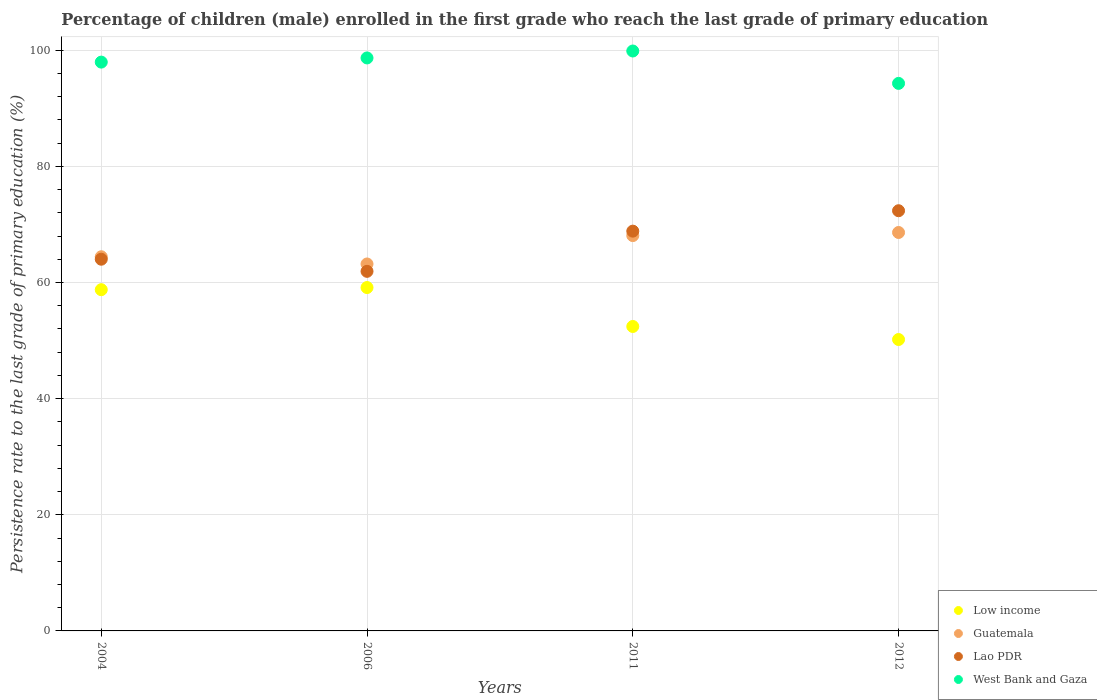How many different coloured dotlines are there?
Provide a short and direct response. 4. What is the persistence rate of children in Lao PDR in 2006?
Ensure brevity in your answer.  61.93. Across all years, what is the maximum persistence rate of children in Low income?
Keep it short and to the point. 59.14. Across all years, what is the minimum persistence rate of children in Low income?
Offer a very short reply. 50.18. What is the total persistence rate of children in Guatemala in the graph?
Your response must be concise. 264.33. What is the difference between the persistence rate of children in West Bank and Gaza in 2004 and that in 2006?
Give a very brief answer. -0.72. What is the difference between the persistence rate of children in West Bank and Gaza in 2006 and the persistence rate of children in Low income in 2004?
Make the answer very short. 39.91. What is the average persistence rate of children in West Bank and Gaza per year?
Your answer should be very brief. 97.7. In the year 2004, what is the difference between the persistence rate of children in Guatemala and persistence rate of children in West Bank and Gaza?
Offer a very short reply. -33.52. What is the ratio of the persistence rate of children in West Bank and Gaza in 2006 to that in 2012?
Make the answer very short. 1.05. What is the difference between the highest and the second highest persistence rate of children in Lao PDR?
Your answer should be compact. 3.52. What is the difference between the highest and the lowest persistence rate of children in Lao PDR?
Provide a succinct answer. 10.44. Is the sum of the persistence rate of children in Low income in 2011 and 2012 greater than the maximum persistence rate of children in West Bank and Gaza across all years?
Offer a very short reply. Yes. Is it the case that in every year, the sum of the persistence rate of children in Lao PDR and persistence rate of children in Low income  is greater than the sum of persistence rate of children in West Bank and Gaza and persistence rate of children in Guatemala?
Offer a very short reply. No. Does the persistence rate of children in Low income monotonically increase over the years?
Give a very brief answer. No. Is the persistence rate of children in West Bank and Gaza strictly greater than the persistence rate of children in Lao PDR over the years?
Keep it short and to the point. Yes. Is the persistence rate of children in Low income strictly less than the persistence rate of children in West Bank and Gaza over the years?
Provide a short and direct response. Yes. How many dotlines are there?
Provide a succinct answer. 4. How many years are there in the graph?
Offer a very short reply. 4. Are the values on the major ticks of Y-axis written in scientific E-notation?
Offer a terse response. No. Does the graph contain any zero values?
Ensure brevity in your answer.  No. How many legend labels are there?
Your response must be concise. 4. What is the title of the graph?
Provide a short and direct response. Percentage of children (male) enrolled in the first grade who reach the last grade of primary education. What is the label or title of the X-axis?
Your answer should be very brief. Years. What is the label or title of the Y-axis?
Your answer should be compact. Persistence rate to the last grade of primary education (%). What is the Persistence rate to the last grade of primary education (%) in Low income in 2004?
Offer a very short reply. 58.77. What is the Persistence rate to the last grade of primary education (%) of Guatemala in 2004?
Keep it short and to the point. 64.44. What is the Persistence rate to the last grade of primary education (%) in Lao PDR in 2004?
Ensure brevity in your answer.  64.01. What is the Persistence rate to the last grade of primary education (%) of West Bank and Gaza in 2004?
Offer a very short reply. 97.96. What is the Persistence rate to the last grade of primary education (%) in Low income in 2006?
Make the answer very short. 59.14. What is the Persistence rate to the last grade of primary education (%) in Guatemala in 2006?
Make the answer very short. 63.19. What is the Persistence rate to the last grade of primary education (%) of Lao PDR in 2006?
Offer a very short reply. 61.93. What is the Persistence rate to the last grade of primary education (%) in West Bank and Gaza in 2006?
Provide a short and direct response. 98.68. What is the Persistence rate to the last grade of primary education (%) in Low income in 2011?
Make the answer very short. 52.43. What is the Persistence rate to the last grade of primary education (%) in Guatemala in 2011?
Provide a short and direct response. 68.08. What is the Persistence rate to the last grade of primary education (%) of Lao PDR in 2011?
Ensure brevity in your answer.  68.85. What is the Persistence rate to the last grade of primary education (%) in West Bank and Gaza in 2011?
Make the answer very short. 99.87. What is the Persistence rate to the last grade of primary education (%) of Low income in 2012?
Offer a terse response. 50.18. What is the Persistence rate to the last grade of primary education (%) in Guatemala in 2012?
Your answer should be compact. 68.62. What is the Persistence rate to the last grade of primary education (%) of Lao PDR in 2012?
Give a very brief answer. 72.36. What is the Persistence rate to the last grade of primary education (%) of West Bank and Gaza in 2012?
Offer a terse response. 94.29. Across all years, what is the maximum Persistence rate to the last grade of primary education (%) of Low income?
Your answer should be very brief. 59.14. Across all years, what is the maximum Persistence rate to the last grade of primary education (%) in Guatemala?
Provide a short and direct response. 68.62. Across all years, what is the maximum Persistence rate to the last grade of primary education (%) of Lao PDR?
Offer a very short reply. 72.36. Across all years, what is the maximum Persistence rate to the last grade of primary education (%) of West Bank and Gaza?
Provide a succinct answer. 99.87. Across all years, what is the minimum Persistence rate to the last grade of primary education (%) in Low income?
Offer a terse response. 50.18. Across all years, what is the minimum Persistence rate to the last grade of primary education (%) in Guatemala?
Provide a short and direct response. 63.19. Across all years, what is the minimum Persistence rate to the last grade of primary education (%) of Lao PDR?
Offer a very short reply. 61.93. Across all years, what is the minimum Persistence rate to the last grade of primary education (%) in West Bank and Gaza?
Ensure brevity in your answer.  94.29. What is the total Persistence rate to the last grade of primary education (%) in Low income in the graph?
Give a very brief answer. 220.52. What is the total Persistence rate to the last grade of primary education (%) in Guatemala in the graph?
Offer a very short reply. 264.33. What is the total Persistence rate to the last grade of primary education (%) in Lao PDR in the graph?
Give a very brief answer. 267.15. What is the total Persistence rate to the last grade of primary education (%) in West Bank and Gaza in the graph?
Give a very brief answer. 390.8. What is the difference between the Persistence rate to the last grade of primary education (%) in Low income in 2004 and that in 2006?
Offer a very short reply. -0.37. What is the difference between the Persistence rate to the last grade of primary education (%) in Guatemala in 2004 and that in 2006?
Offer a very short reply. 1.24. What is the difference between the Persistence rate to the last grade of primary education (%) in Lao PDR in 2004 and that in 2006?
Give a very brief answer. 2.09. What is the difference between the Persistence rate to the last grade of primary education (%) in West Bank and Gaza in 2004 and that in 2006?
Your answer should be compact. -0.72. What is the difference between the Persistence rate to the last grade of primary education (%) of Low income in 2004 and that in 2011?
Offer a terse response. 6.34. What is the difference between the Persistence rate to the last grade of primary education (%) of Guatemala in 2004 and that in 2011?
Your answer should be very brief. -3.65. What is the difference between the Persistence rate to the last grade of primary education (%) in Lao PDR in 2004 and that in 2011?
Ensure brevity in your answer.  -4.83. What is the difference between the Persistence rate to the last grade of primary education (%) in West Bank and Gaza in 2004 and that in 2011?
Make the answer very short. -1.91. What is the difference between the Persistence rate to the last grade of primary education (%) in Low income in 2004 and that in 2012?
Make the answer very short. 8.58. What is the difference between the Persistence rate to the last grade of primary education (%) in Guatemala in 2004 and that in 2012?
Offer a terse response. -4.18. What is the difference between the Persistence rate to the last grade of primary education (%) in Lao PDR in 2004 and that in 2012?
Keep it short and to the point. -8.35. What is the difference between the Persistence rate to the last grade of primary education (%) of West Bank and Gaza in 2004 and that in 2012?
Give a very brief answer. 3.66. What is the difference between the Persistence rate to the last grade of primary education (%) of Low income in 2006 and that in 2011?
Your answer should be compact. 6.71. What is the difference between the Persistence rate to the last grade of primary education (%) in Guatemala in 2006 and that in 2011?
Your response must be concise. -4.89. What is the difference between the Persistence rate to the last grade of primary education (%) in Lao PDR in 2006 and that in 2011?
Offer a very short reply. -6.92. What is the difference between the Persistence rate to the last grade of primary education (%) of West Bank and Gaza in 2006 and that in 2011?
Give a very brief answer. -1.19. What is the difference between the Persistence rate to the last grade of primary education (%) in Low income in 2006 and that in 2012?
Offer a terse response. 8.95. What is the difference between the Persistence rate to the last grade of primary education (%) in Guatemala in 2006 and that in 2012?
Ensure brevity in your answer.  -5.42. What is the difference between the Persistence rate to the last grade of primary education (%) in Lao PDR in 2006 and that in 2012?
Provide a short and direct response. -10.44. What is the difference between the Persistence rate to the last grade of primary education (%) in West Bank and Gaza in 2006 and that in 2012?
Your answer should be compact. 4.38. What is the difference between the Persistence rate to the last grade of primary education (%) in Low income in 2011 and that in 2012?
Provide a succinct answer. 2.25. What is the difference between the Persistence rate to the last grade of primary education (%) of Guatemala in 2011 and that in 2012?
Make the answer very short. -0.53. What is the difference between the Persistence rate to the last grade of primary education (%) of Lao PDR in 2011 and that in 2012?
Give a very brief answer. -3.52. What is the difference between the Persistence rate to the last grade of primary education (%) in West Bank and Gaza in 2011 and that in 2012?
Offer a terse response. 5.58. What is the difference between the Persistence rate to the last grade of primary education (%) of Low income in 2004 and the Persistence rate to the last grade of primary education (%) of Guatemala in 2006?
Your answer should be very brief. -4.43. What is the difference between the Persistence rate to the last grade of primary education (%) of Low income in 2004 and the Persistence rate to the last grade of primary education (%) of Lao PDR in 2006?
Offer a very short reply. -3.16. What is the difference between the Persistence rate to the last grade of primary education (%) of Low income in 2004 and the Persistence rate to the last grade of primary education (%) of West Bank and Gaza in 2006?
Offer a very short reply. -39.91. What is the difference between the Persistence rate to the last grade of primary education (%) of Guatemala in 2004 and the Persistence rate to the last grade of primary education (%) of Lao PDR in 2006?
Your answer should be compact. 2.51. What is the difference between the Persistence rate to the last grade of primary education (%) in Guatemala in 2004 and the Persistence rate to the last grade of primary education (%) in West Bank and Gaza in 2006?
Keep it short and to the point. -34.24. What is the difference between the Persistence rate to the last grade of primary education (%) in Lao PDR in 2004 and the Persistence rate to the last grade of primary education (%) in West Bank and Gaza in 2006?
Make the answer very short. -34.66. What is the difference between the Persistence rate to the last grade of primary education (%) of Low income in 2004 and the Persistence rate to the last grade of primary education (%) of Guatemala in 2011?
Give a very brief answer. -9.32. What is the difference between the Persistence rate to the last grade of primary education (%) of Low income in 2004 and the Persistence rate to the last grade of primary education (%) of Lao PDR in 2011?
Your answer should be very brief. -10.08. What is the difference between the Persistence rate to the last grade of primary education (%) in Low income in 2004 and the Persistence rate to the last grade of primary education (%) in West Bank and Gaza in 2011?
Your answer should be compact. -41.1. What is the difference between the Persistence rate to the last grade of primary education (%) of Guatemala in 2004 and the Persistence rate to the last grade of primary education (%) of Lao PDR in 2011?
Give a very brief answer. -4.41. What is the difference between the Persistence rate to the last grade of primary education (%) of Guatemala in 2004 and the Persistence rate to the last grade of primary education (%) of West Bank and Gaza in 2011?
Keep it short and to the point. -35.43. What is the difference between the Persistence rate to the last grade of primary education (%) in Lao PDR in 2004 and the Persistence rate to the last grade of primary education (%) in West Bank and Gaza in 2011?
Ensure brevity in your answer.  -35.86. What is the difference between the Persistence rate to the last grade of primary education (%) in Low income in 2004 and the Persistence rate to the last grade of primary education (%) in Guatemala in 2012?
Offer a very short reply. -9.85. What is the difference between the Persistence rate to the last grade of primary education (%) in Low income in 2004 and the Persistence rate to the last grade of primary education (%) in Lao PDR in 2012?
Offer a very short reply. -13.6. What is the difference between the Persistence rate to the last grade of primary education (%) of Low income in 2004 and the Persistence rate to the last grade of primary education (%) of West Bank and Gaza in 2012?
Provide a succinct answer. -35.53. What is the difference between the Persistence rate to the last grade of primary education (%) of Guatemala in 2004 and the Persistence rate to the last grade of primary education (%) of Lao PDR in 2012?
Your answer should be very brief. -7.93. What is the difference between the Persistence rate to the last grade of primary education (%) in Guatemala in 2004 and the Persistence rate to the last grade of primary education (%) in West Bank and Gaza in 2012?
Keep it short and to the point. -29.86. What is the difference between the Persistence rate to the last grade of primary education (%) of Lao PDR in 2004 and the Persistence rate to the last grade of primary education (%) of West Bank and Gaza in 2012?
Make the answer very short. -30.28. What is the difference between the Persistence rate to the last grade of primary education (%) in Low income in 2006 and the Persistence rate to the last grade of primary education (%) in Guatemala in 2011?
Provide a short and direct response. -8.95. What is the difference between the Persistence rate to the last grade of primary education (%) of Low income in 2006 and the Persistence rate to the last grade of primary education (%) of Lao PDR in 2011?
Provide a short and direct response. -9.71. What is the difference between the Persistence rate to the last grade of primary education (%) in Low income in 2006 and the Persistence rate to the last grade of primary education (%) in West Bank and Gaza in 2011?
Your answer should be compact. -40.74. What is the difference between the Persistence rate to the last grade of primary education (%) in Guatemala in 2006 and the Persistence rate to the last grade of primary education (%) in Lao PDR in 2011?
Give a very brief answer. -5.65. What is the difference between the Persistence rate to the last grade of primary education (%) of Guatemala in 2006 and the Persistence rate to the last grade of primary education (%) of West Bank and Gaza in 2011?
Your answer should be compact. -36.68. What is the difference between the Persistence rate to the last grade of primary education (%) in Lao PDR in 2006 and the Persistence rate to the last grade of primary education (%) in West Bank and Gaza in 2011?
Give a very brief answer. -37.94. What is the difference between the Persistence rate to the last grade of primary education (%) in Low income in 2006 and the Persistence rate to the last grade of primary education (%) in Guatemala in 2012?
Offer a very short reply. -9.48. What is the difference between the Persistence rate to the last grade of primary education (%) of Low income in 2006 and the Persistence rate to the last grade of primary education (%) of Lao PDR in 2012?
Keep it short and to the point. -13.23. What is the difference between the Persistence rate to the last grade of primary education (%) in Low income in 2006 and the Persistence rate to the last grade of primary education (%) in West Bank and Gaza in 2012?
Keep it short and to the point. -35.16. What is the difference between the Persistence rate to the last grade of primary education (%) in Guatemala in 2006 and the Persistence rate to the last grade of primary education (%) in Lao PDR in 2012?
Offer a very short reply. -9.17. What is the difference between the Persistence rate to the last grade of primary education (%) in Guatemala in 2006 and the Persistence rate to the last grade of primary education (%) in West Bank and Gaza in 2012?
Your answer should be very brief. -31.1. What is the difference between the Persistence rate to the last grade of primary education (%) in Lao PDR in 2006 and the Persistence rate to the last grade of primary education (%) in West Bank and Gaza in 2012?
Keep it short and to the point. -32.37. What is the difference between the Persistence rate to the last grade of primary education (%) in Low income in 2011 and the Persistence rate to the last grade of primary education (%) in Guatemala in 2012?
Give a very brief answer. -16.19. What is the difference between the Persistence rate to the last grade of primary education (%) in Low income in 2011 and the Persistence rate to the last grade of primary education (%) in Lao PDR in 2012?
Offer a terse response. -19.93. What is the difference between the Persistence rate to the last grade of primary education (%) of Low income in 2011 and the Persistence rate to the last grade of primary education (%) of West Bank and Gaza in 2012?
Ensure brevity in your answer.  -41.86. What is the difference between the Persistence rate to the last grade of primary education (%) in Guatemala in 2011 and the Persistence rate to the last grade of primary education (%) in Lao PDR in 2012?
Make the answer very short. -4.28. What is the difference between the Persistence rate to the last grade of primary education (%) of Guatemala in 2011 and the Persistence rate to the last grade of primary education (%) of West Bank and Gaza in 2012?
Give a very brief answer. -26.21. What is the difference between the Persistence rate to the last grade of primary education (%) in Lao PDR in 2011 and the Persistence rate to the last grade of primary education (%) in West Bank and Gaza in 2012?
Your answer should be very brief. -25.45. What is the average Persistence rate to the last grade of primary education (%) of Low income per year?
Ensure brevity in your answer.  55.13. What is the average Persistence rate to the last grade of primary education (%) in Guatemala per year?
Provide a succinct answer. 66.08. What is the average Persistence rate to the last grade of primary education (%) of Lao PDR per year?
Give a very brief answer. 66.79. What is the average Persistence rate to the last grade of primary education (%) in West Bank and Gaza per year?
Give a very brief answer. 97.7. In the year 2004, what is the difference between the Persistence rate to the last grade of primary education (%) in Low income and Persistence rate to the last grade of primary education (%) in Guatemala?
Provide a succinct answer. -5.67. In the year 2004, what is the difference between the Persistence rate to the last grade of primary education (%) of Low income and Persistence rate to the last grade of primary education (%) of Lao PDR?
Provide a short and direct response. -5.25. In the year 2004, what is the difference between the Persistence rate to the last grade of primary education (%) in Low income and Persistence rate to the last grade of primary education (%) in West Bank and Gaza?
Your answer should be compact. -39.19. In the year 2004, what is the difference between the Persistence rate to the last grade of primary education (%) of Guatemala and Persistence rate to the last grade of primary education (%) of Lao PDR?
Ensure brevity in your answer.  0.42. In the year 2004, what is the difference between the Persistence rate to the last grade of primary education (%) of Guatemala and Persistence rate to the last grade of primary education (%) of West Bank and Gaza?
Make the answer very short. -33.52. In the year 2004, what is the difference between the Persistence rate to the last grade of primary education (%) in Lao PDR and Persistence rate to the last grade of primary education (%) in West Bank and Gaza?
Your answer should be very brief. -33.94. In the year 2006, what is the difference between the Persistence rate to the last grade of primary education (%) in Low income and Persistence rate to the last grade of primary education (%) in Guatemala?
Your answer should be compact. -4.06. In the year 2006, what is the difference between the Persistence rate to the last grade of primary education (%) of Low income and Persistence rate to the last grade of primary education (%) of Lao PDR?
Provide a succinct answer. -2.79. In the year 2006, what is the difference between the Persistence rate to the last grade of primary education (%) in Low income and Persistence rate to the last grade of primary education (%) in West Bank and Gaza?
Your answer should be very brief. -39.54. In the year 2006, what is the difference between the Persistence rate to the last grade of primary education (%) in Guatemala and Persistence rate to the last grade of primary education (%) in Lao PDR?
Offer a very short reply. 1.27. In the year 2006, what is the difference between the Persistence rate to the last grade of primary education (%) of Guatemala and Persistence rate to the last grade of primary education (%) of West Bank and Gaza?
Make the answer very short. -35.48. In the year 2006, what is the difference between the Persistence rate to the last grade of primary education (%) of Lao PDR and Persistence rate to the last grade of primary education (%) of West Bank and Gaza?
Ensure brevity in your answer.  -36.75. In the year 2011, what is the difference between the Persistence rate to the last grade of primary education (%) in Low income and Persistence rate to the last grade of primary education (%) in Guatemala?
Your answer should be very brief. -15.65. In the year 2011, what is the difference between the Persistence rate to the last grade of primary education (%) in Low income and Persistence rate to the last grade of primary education (%) in Lao PDR?
Provide a short and direct response. -16.42. In the year 2011, what is the difference between the Persistence rate to the last grade of primary education (%) in Low income and Persistence rate to the last grade of primary education (%) in West Bank and Gaza?
Provide a short and direct response. -47.44. In the year 2011, what is the difference between the Persistence rate to the last grade of primary education (%) of Guatemala and Persistence rate to the last grade of primary education (%) of Lao PDR?
Offer a very short reply. -0.77. In the year 2011, what is the difference between the Persistence rate to the last grade of primary education (%) of Guatemala and Persistence rate to the last grade of primary education (%) of West Bank and Gaza?
Give a very brief answer. -31.79. In the year 2011, what is the difference between the Persistence rate to the last grade of primary education (%) of Lao PDR and Persistence rate to the last grade of primary education (%) of West Bank and Gaza?
Provide a succinct answer. -31.02. In the year 2012, what is the difference between the Persistence rate to the last grade of primary education (%) in Low income and Persistence rate to the last grade of primary education (%) in Guatemala?
Offer a terse response. -18.43. In the year 2012, what is the difference between the Persistence rate to the last grade of primary education (%) in Low income and Persistence rate to the last grade of primary education (%) in Lao PDR?
Your answer should be compact. -22.18. In the year 2012, what is the difference between the Persistence rate to the last grade of primary education (%) of Low income and Persistence rate to the last grade of primary education (%) of West Bank and Gaza?
Make the answer very short. -44.11. In the year 2012, what is the difference between the Persistence rate to the last grade of primary education (%) of Guatemala and Persistence rate to the last grade of primary education (%) of Lao PDR?
Your answer should be compact. -3.75. In the year 2012, what is the difference between the Persistence rate to the last grade of primary education (%) in Guatemala and Persistence rate to the last grade of primary education (%) in West Bank and Gaza?
Your answer should be compact. -25.68. In the year 2012, what is the difference between the Persistence rate to the last grade of primary education (%) of Lao PDR and Persistence rate to the last grade of primary education (%) of West Bank and Gaza?
Your answer should be very brief. -21.93. What is the ratio of the Persistence rate to the last grade of primary education (%) of Low income in 2004 to that in 2006?
Provide a short and direct response. 0.99. What is the ratio of the Persistence rate to the last grade of primary education (%) in Guatemala in 2004 to that in 2006?
Make the answer very short. 1.02. What is the ratio of the Persistence rate to the last grade of primary education (%) in Lao PDR in 2004 to that in 2006?
Give a very brief answer. 1.03. What is the ratio of the Persistence rate to the last grade of primary education (%) of West Bank and Gaza in 2004 to that in 2006?
Offer a very short reply. 0.99. What is the ratio of the Persistence rate to the last grade of primary education (%) in Low income in 2004 to that in 2011?
Offer a very short reply. 1.12. What is the ratio of the Persistence rate to the last grade of primary education (%) of Guatemala in 2004 to that in 2011?
Provide a short and direct response. 0.95. What is the ratio of the Persistence rate to the last grade of primary education (%) in Lao PDR in 2004 to that in 2011?
Your answer should be very brief. 0.93. What is the ratio of the Persistence rate to the last grade of primary education (%) of West Bank and Gaza in 2004 to that in 2011?
Your answer should be very brief. 0.98. What is the ratio of the Persistence rate to the last grade of primary education (%) in Low income in 2004 to that in 2012?
Keep it short and to the point. 1.17. What is the ratio of the Persistence rate to the last grade of primary education (%) of Guatemala in 2004 to that in 2012?
Make the answer very short. 0.94. What is the ratio of the Persistence rate to the last grade of primary education (%) of Lao PDR in 2004 to that in 2012?
Ensure brevity in your answer.  0.88. What is the ratio of the Persistence rate to the last grade of primary education (%) in West Bank and Gaza in 2004 to that in 2012?
Give a very brief answer. 1.04. What is the ratio of the Persistence rate to the last grade of primary education (%) in Low income in 2006 to that in 2011?
Keep it short and to the point. 1.13. What is the ratio of the Persistence rate to the last grade of primary education (%) of Guatemala in 2006 to that in 2011?
Ensure brevity in your answer.  0.93. What is the ratio of the Persistence rate to the last grade of primary education (%) in Lao PDR in 2006 to that in 2011?
Provide a succinct answer. 0.9. What is the ratio of the Persistence rate to the last grade of primary education (%) in West Bank and Gaza in 2006 to that in 2011?
Offer a terse response. 0.99. What is the ratio of the Persistence rate to the last grade of primary education (%) of Low income in 2006 to that in 2012?
Your response must be concise. 1.18. What is the ratio of the Persistence rate to the last grade of primary education (%) of Guatemala in 2006 to that in 2012?
Your answer should be very brief. 0.92. What is the ratio of the Persistence rate to the last grade of primary education (%) in Lao PDR in 2006 to that in 2012?
Your answer should be compact. 0.86. What is the ratio of the Persistence rate to the last grade of primary education (%) in West Bank and Gaza in 2006 to that in 2012?
Offer a terse response. 1.05. What is the ratio of the Persistence rate to the last grade of primary education (%) in Low income in 2011 to that in 2012?
Offer a very short reply. 1.04. What is the ratio of the Persistence rate to the last grade of primary education (%) in Guatemala in 2011 to that in 2012?
Offer a terse response. 0.99. What is the ratio of the Persistence rate to the last grade of primary education (%) of Lao PDR in 2011 to that in 2012?
Provide a short and direct response. 0.95. What is the ratio of the Persistence rate to the last grade of primary education (%) of West Bank and Gaza in 2011 to that in 2012?
Offer a very short reply. 1.06. What is the difference between the highest and the second highest Persistence rate to the last grade of primary education (%) of Low income?
Offer a terse response. 0.37. What is the difference between the highest and the second highest Persistence rate to the last grade of primary education (%) of Guatemala?
Offer a terse response. 0.53. What is the difference between the highest and the second highest Persistence rate to the last grade of primary education (%) of Lao PDR?
Your answer should be compact. 3.52. What is the difference between the highest and the second highest Persistence rate to the last grade of primary education (%) of West Bank and Gaza?
Your answer should be compact. 1.19. What is the difference between the highest and the lowest Persistence rate to the last grade of primary education (%) in Low income?
Ensure brevity in your answer.  8.95. What is the difference between the highest and the lowest Persistence rate to the last grade of primary education (%) in Guatemala?
Provide a succinct answer. 5.42. What is the difference between the highest and the lowest Persistence rate to the last grade of primary education (%) in Lao PDR?
Offer a terse response. 10.44. What is the difference between the highest and the lowest Persistence rate to the last grade of primary education (%) of West Bank and Gaza?
Provide a short and direct response. 5.58. 